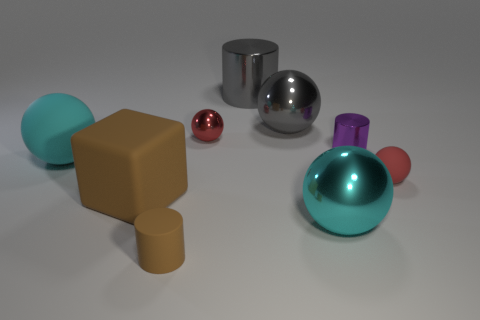Subtract all spheres. How many objects are left? 4 Subtract all tiny red balls. Subtract all gray metal cylinders. How many objects are left? 6 Add 2 tiny shiny balls. How many tiny shiny balls are left? 3 Add 4 cylinders. How many cylinders exist? 7 Subtract 1 brown blocks. How many objects are left? 8 